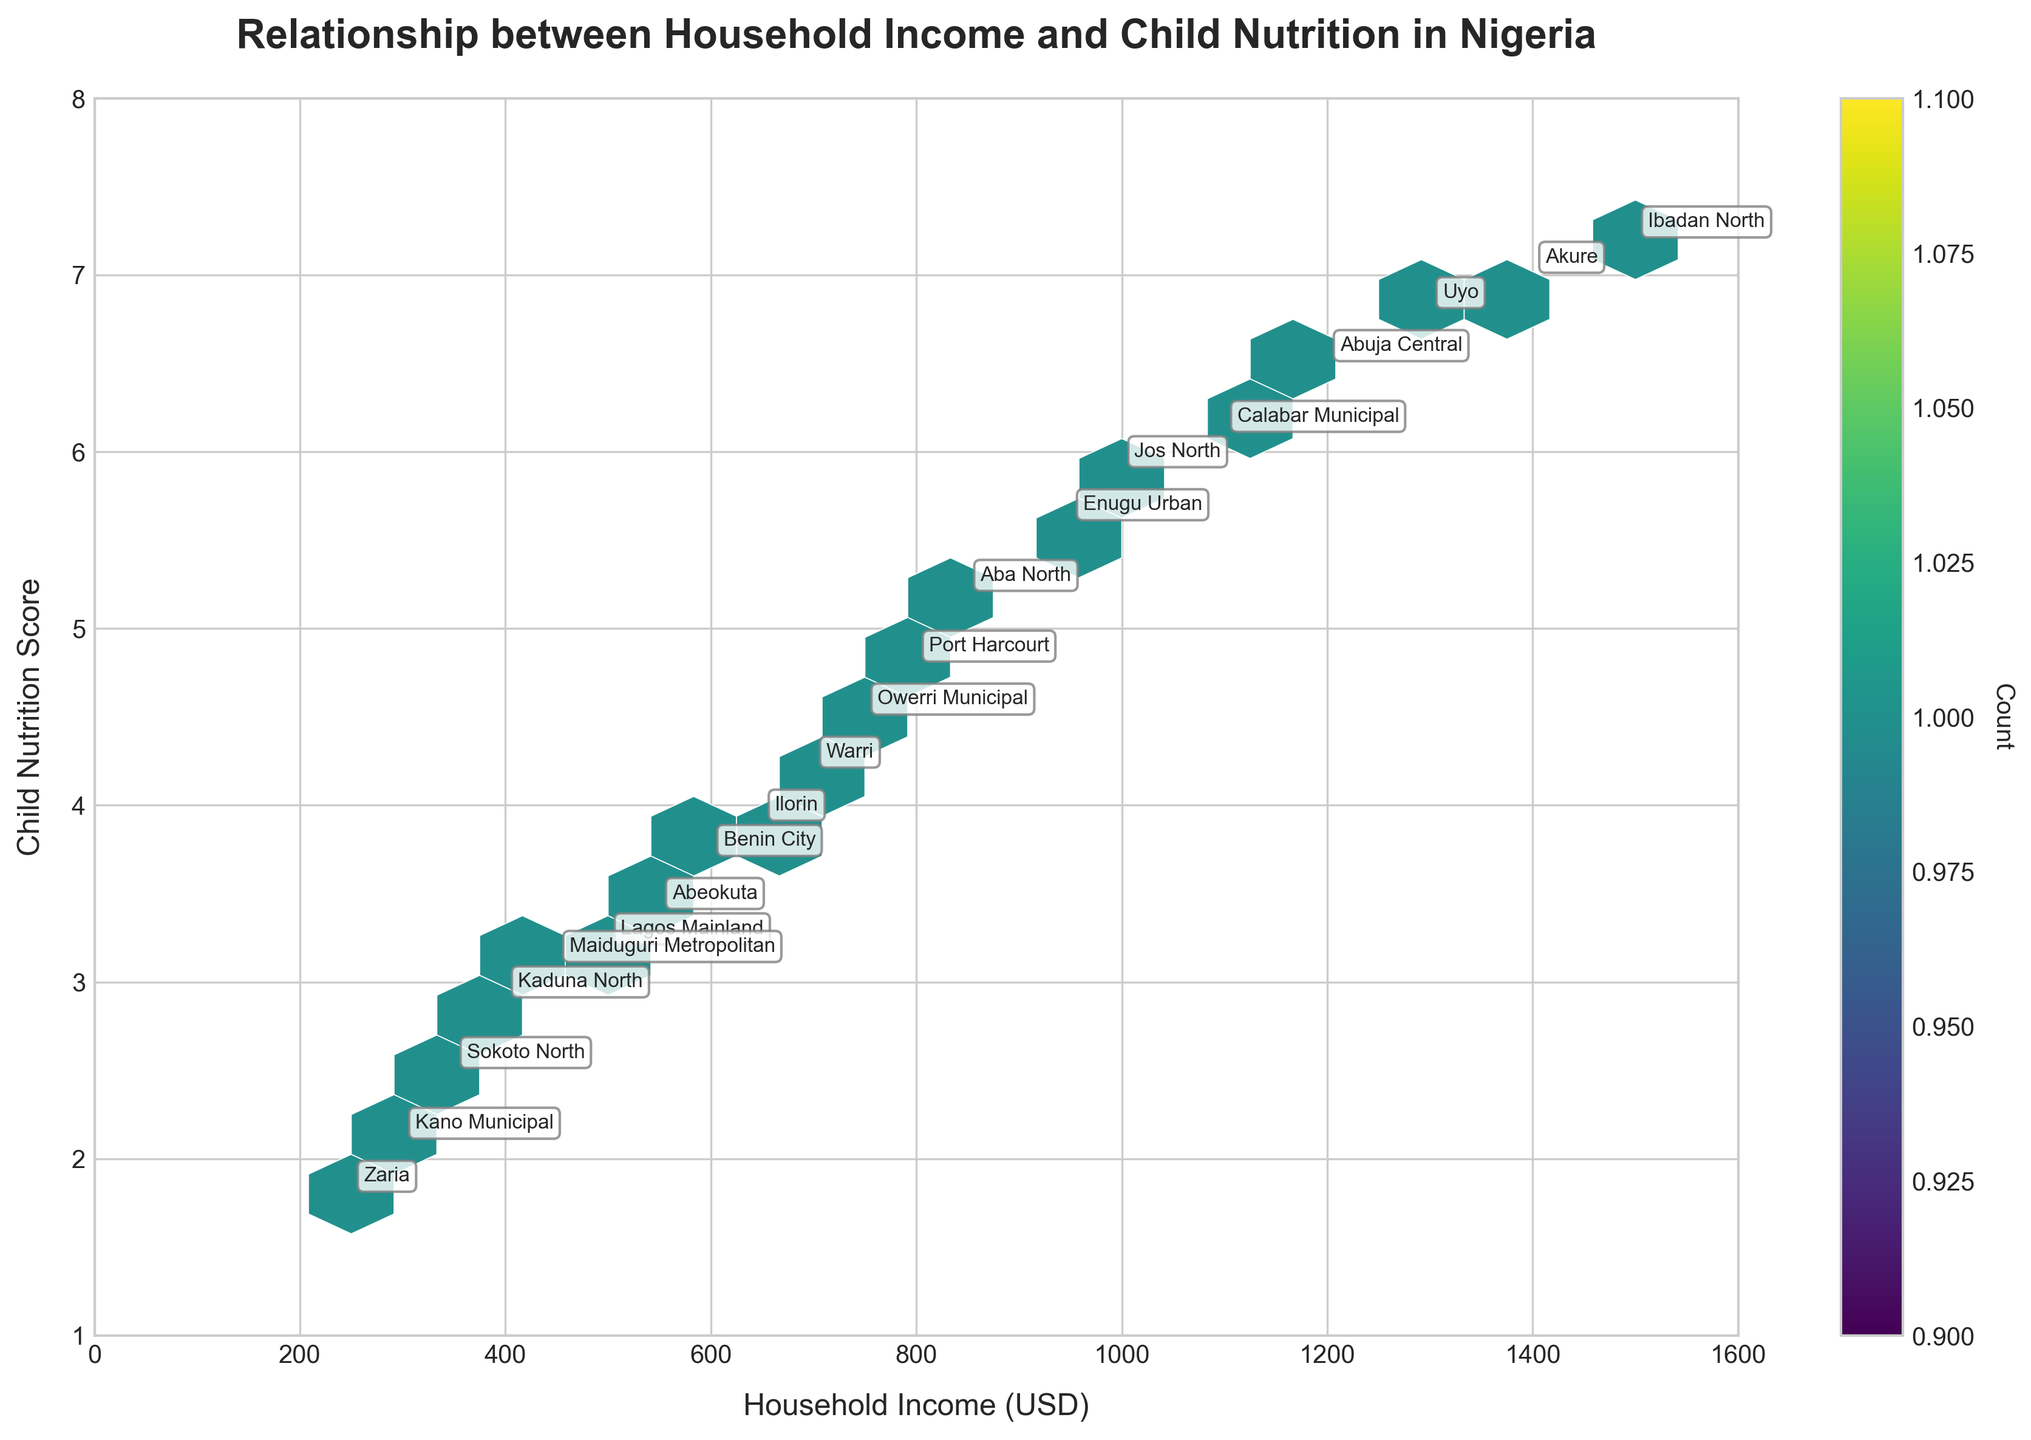What's the title of the plot? The title of the plot is written at the top of the figure, usually in a larger or bold font. The title here clearly reads "Relationship between Household Income and Child Nutrition in Nigeria".
Answer: Relationship between Household Income and Child Nutrition in Nigeria What are the x and y axes representing? The x-axis represents "Household Income (USD)" and the y-axis represents "Child Nutrition Score". This can be seen from the labels on each axis.
Answer: Household Income (USD) and Child Nutrition Score Which community has the highest child nutrition score? To determine this, look for the data point with the highest y-value. The highest child nutrition score is 7.2, and the annotation next to this data point is "Ibadan North".
Answer: Ibadan North How many color bins are represented in the plot? Look at the color scale (color bar) alongside the plot which represents the count. It starts from the minimum and varies, typically with a gradient. The scale markings will provide this information. Here, the bin count starts from 1.
Answer: Varies (starting from 1) Which community has the lowest household income and what is the corresponding child nutrition score? Locate the data point with the lowest x-value. This point has a household income of 250 USD and the community is "Zaria". The corresponding child nutrition score is 1.8 as seen from the y-value.
Answer: Zaria with a score of 1.8 What can be inferred by the general grouping of the hexagons on the plot? By observing the density and concentration of the hexagons, one can infer whether there is a common range where most data points lie. A higher density zone indicates more data points within that range.
Answer: General income level and nutrition rate concentration Which community has a child nutrition score closely aligned with the mean score of the plot? First, calculate the mean child nutrition score from the given data. Comparing this average to the y-values will show the community closest to this mean.
Answer: Check data to determine Is there a visible trend between household income and child nutrition score? By examining the overall scatter of hexagons, one can observe if there appears to be an upward or downward trend. Here, there's an indication that higher household income tends to correlate with higher child nutrition scores.
Answer: Positive correlation Which two communities have household incomes around 950 and what is their child nutrition score? Identify the communities annotated near the x-value of 950. These are Enugu Urban (950, 5.6) and Jos North (1000, 5.9). Their corresponding nutrition scores are 5.6 and 5.9.
Answer: Enugu Urban with 5.6 and Jos North with 5.9 Considering the given data, what is the average child nutrition score across all communities? Sum all given child nutrition scores and divide by the number of communities. Calculate (3.2 + 6.5 + 2.1 + 4.8 + 7.2 + 2.9 + 5.6 + 3.7 + 6.1 + 2.5 + 4.5 + 6.8 + 3.4 + 5.9 + 3.1 + 4.2 + 7.0 + 3.9 + 5.2 + 1.8) / 20 = 4.68.
Answer: 4.68 